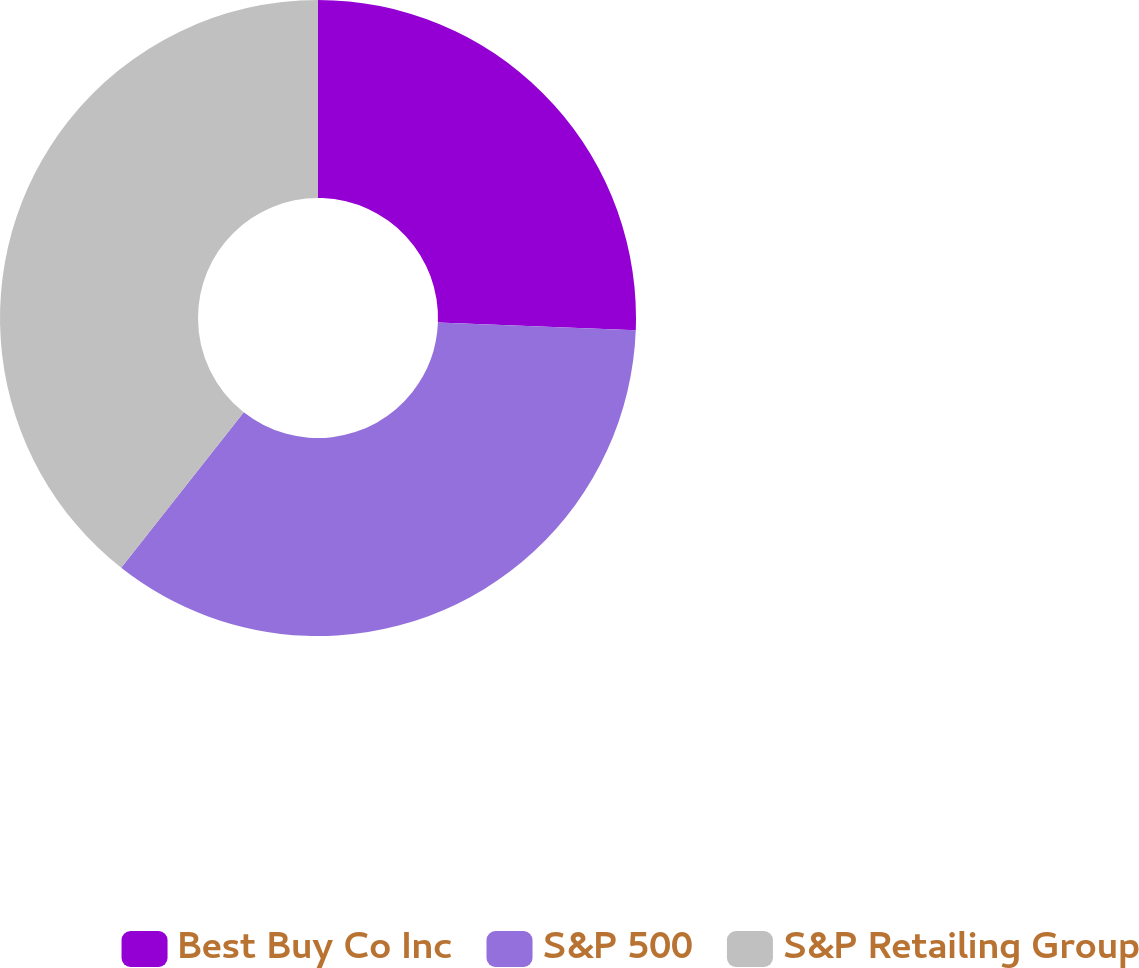Convert chart to OTSL. <chart><loc_0><loc_0><loc_500><loc_500><pie_chart><fcel>Best Buy Co Inc<fcel>S&P 500<fcel>S&P Retailing Group<nl><fcel>25.61%<fcel>35.01%<fcel>39.38%<nl></chart> 